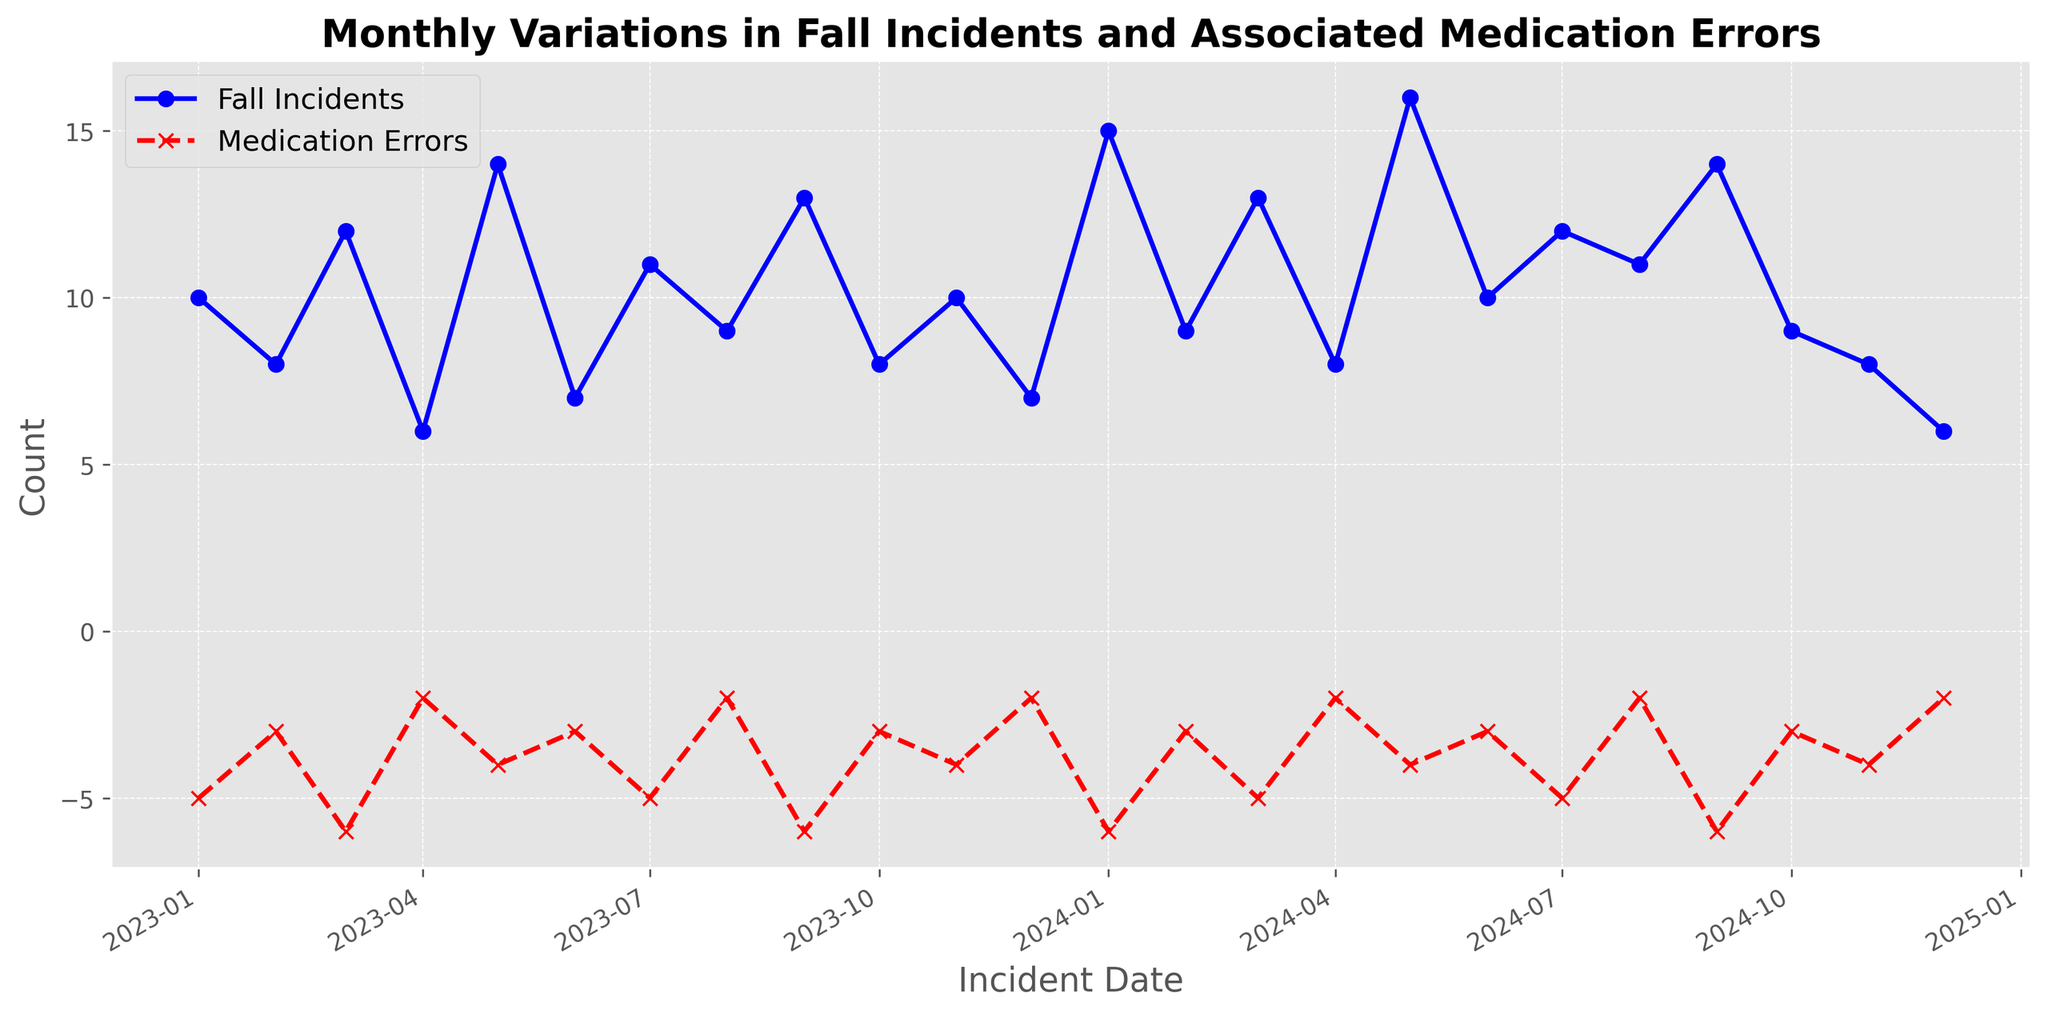What is the overall trend in fall incidents over the two-year period? The trend can be identified by looking at the line representing fall incidents from January 2023 to December 2024. The line shows an overall increase, peaking several times, with the highest value reaching 16 incidents in May 2024.
Answer: Increasing Between January 2023 and December 2024, during which months did medication errors reach their maximum count? By examining the red dashed line representing medication errors, it is clear that the highest point is -6, which occurs in several months: March 2023, September 2023, January 2024, and September 2024.
Answer: March 2023, September 2023, January 2024, September 2024 On average, how many fall incidents occur per month over the entire period shown on the plot? To find the average, sum all monthly fall incidents from January 2023 to December 2024 and then divide by the number of months (24). The sum is (10+8+12+6+14+7+11+9+13+8+10+7+15+9+13+8+16+10+12+11+14+9+8+6) = 240, so the average is 240/24.
Answer: 10 In which month(s) do fall incidents and medication errors share the same trend direction (both increasing or both decreasing) from the previous month? By comparing consecutive months, identify where both fall incidents and medication errors either both increase or both decrease. From January 2023 to February 2023, both fall incidents (10 to 8) and medication errors (-5 to -3) decrease. From June 2023 to July 2023, both incidents (7 to 11) and errors (-3 to -5) increase.
Answer: February 2023, July 2023 During which months are the number of medication errors the same? Look at the red dashed line to find horizontal segments where medication errors are the same for different months. Errors are -3 in February 2023, June 2023, October 2023, February 2024, June 2024, October 2024. Errors are -2 in April 2023, August 2023, December 2023, April 2024, August 2024, December 2024. Errors are also -5 in January 2023, March 2023, July 2023, January 2024, March 2024, July 2024, March 2024.
Answer: February 2023, June 2023, October 2023, February 2024, June 2024, October 2024; April 2023, August 2023, December 2023, April 2024, August 2024, December 2024; January 2023, March 2023, July 2023, January 2024, March 2024, July 2024, March 2024 Which month shows the lowest count of fall incidents, and what is that count? Identify the minimum point on the blue line representing fall incidents. This occurs in December 2024 with a count of 6.
Answer: December 2024, 6 